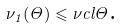<formula> <loc_0><loc_0><loc_500><loc_500>\nu _ { 1 } ( \Theta ) \leqslant \nu c l { \Theta } \text {.}</formula> 